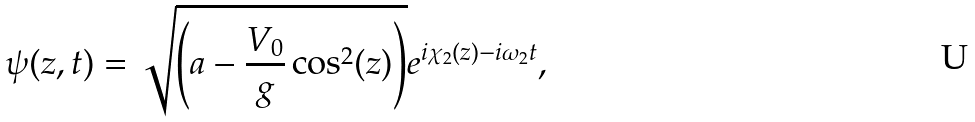<formula> <loc_0><loc_0><loc_500><loc_500>\psi ( z , t ) = \sqrt { \left ( a - \frac { V _ { 0 } } { g } \cos ^ { 2 } ( z ) \right ) } e ^ { i \chi _ { 2 } ( z ) - i \omega _ { 2 } t } ,</formula> 